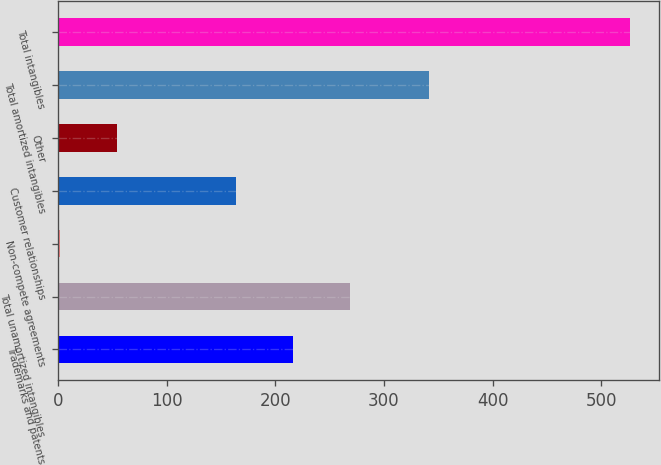<chart> <loc_0><loc_0><loc_500><loc_500><bar_chart><fcel>Trademarks and patents<fcel>Total unamortized intangibles<fcel>Non-compete agreements<fcel>Customer relationships<fcel>Other<fcel>Total amortized intangibles<fcel>Total intangibles<nl><fcel>216.48<fcel>268.96<fcel>1.7<fcel>164<fcel>54.18<fcel>341.5<fcel>526.5<nl></chart> 